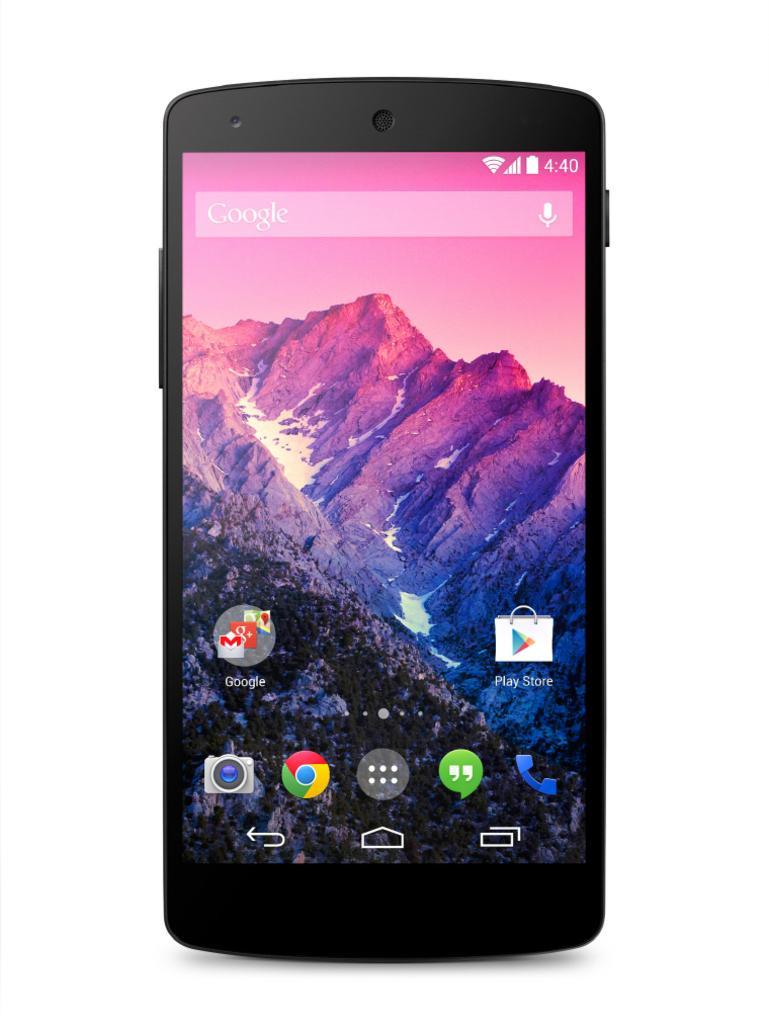Please provide a concise description of this image. In this image I can see a mobile which is black in color and on the screen of the mobile I can see few icons, a mountain and the sky. I can see the white colored background. 